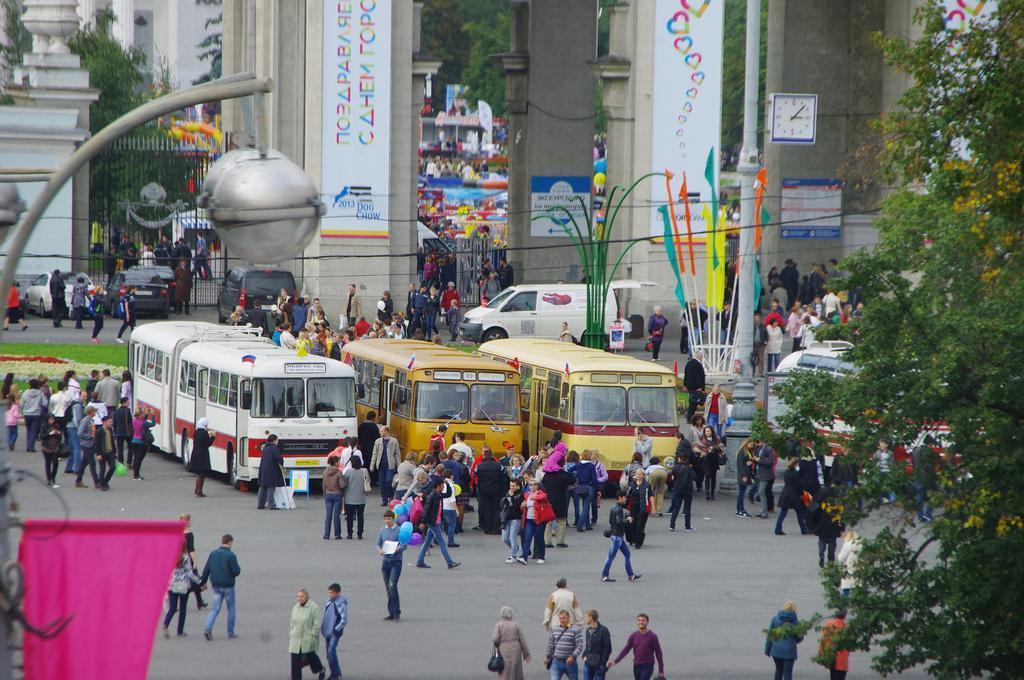How many white buses are in the image?
Give a very brief answer. 1. How many yellow buses are in the image?
Give a very brief answer. 2. How many green buses are there in the image ?
Give a very brief answer. 0. 